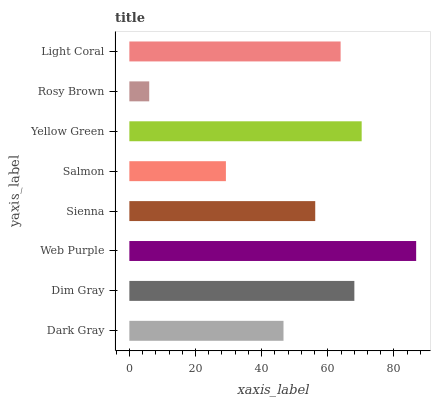Is Rosy Brown the minimum?
Answer yes or no. Yes. Is Web Purple the maximum?
Answer yes or no. Yes. Is Dim Gray the minimum?
Answer yes or no. No. Is Dim Gray the maximum?
Answer yes or no. No. Is Dim Gray greater than Dark Gray?
Answer yes or no. Yes. Is Dark Gray less than Dim Gray?
Answer yes or no. Yes. Is Dark Gray greater than Dim Gray?
Answer yes or no. No. Is Dim Gray less than Dark Gray?
Answer yes or no. No. Is Light Coral the high median?
Answer yes or no. Yes. Is Sienna the low median?
Answer yes or no. Yes. Is Web Purple the high median?
Answer yes or no. No. Is Rosy Brown the low median?
Answer yes or no. No. 